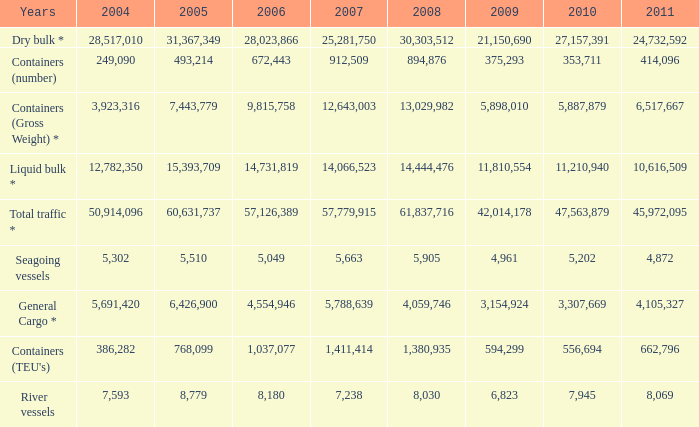What was the total in 2009 for years of river vessels when 2008 was more than 8,030 and 2007 was more than 1,411,414? 0.0. 